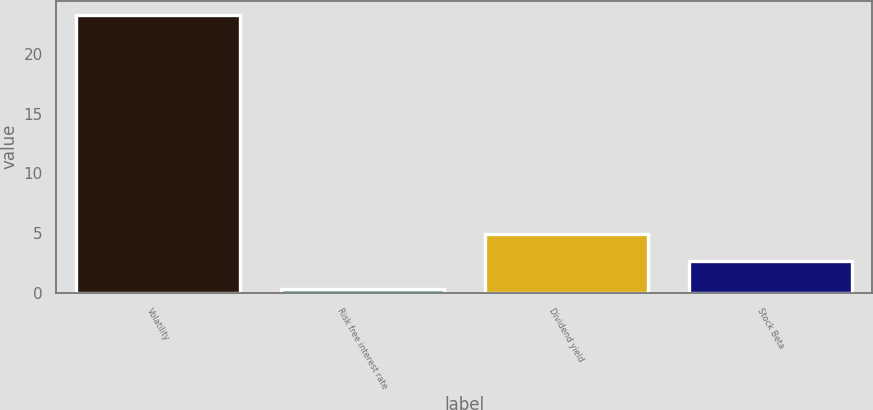Convert chart to OTSL. <chart><loc_0><loc_0><loc_500><loc_500><bar_chart><fcel>Volatility<fcel>Risk free interest rate<fcel>Dividend yield<fcel>Stock Beta<nl><fcel>23.3<fcel>0.33<fcel>4.93<fcel>2.63<nl></chart> 